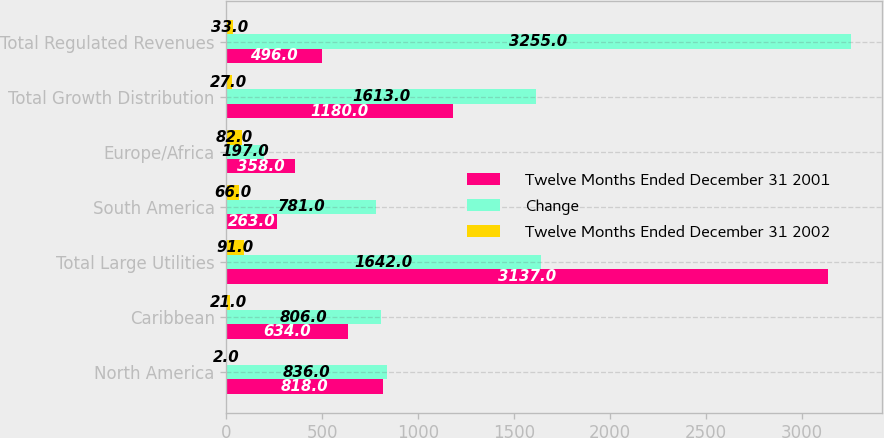Convert chart. <chart><loc_0><loc_0><loc_500><loc_500><stacked_bar_chart><ecel><fcel>North America<fcel>Caribbean<fcel>Total Large Utilities<fcel>South America<fcel>Europe/Africa<fcel>Total Growth Distribution<fcel>Total Regulated Revenues<nl><fcel>Twelve Months Ended December 31 2001<fcel>818<fcel>634<fcel>3137<fcel>263<fcel>358<fcel>1180<fcel>496<nl><fcel>Change<fcel>836<fcel>806<fcel>1642<fcel>781<fcel>197<fcel>1613<fcel>3255<nl><fcel>Twelve Months Ended December 31 2002<fcel>2<fcel>21<fcel>91<fcel>66<fcel>82<fcel>27<fcel>33<nl></chart> 